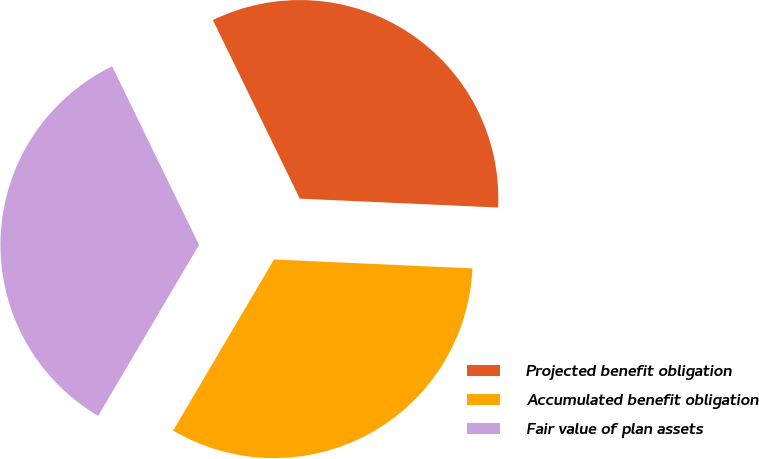Convert chart to OTSL. <chart><loc_0><loc_0><loc_500><loc_500><pie_chart><fcel>Projected benefit obligation<fcel>Accumulated benefit obligation<fcel>Fair value of plan assets<nl><fcel>32.92%<fcel>32.77%<fcel>34.31%<nl></chart> 